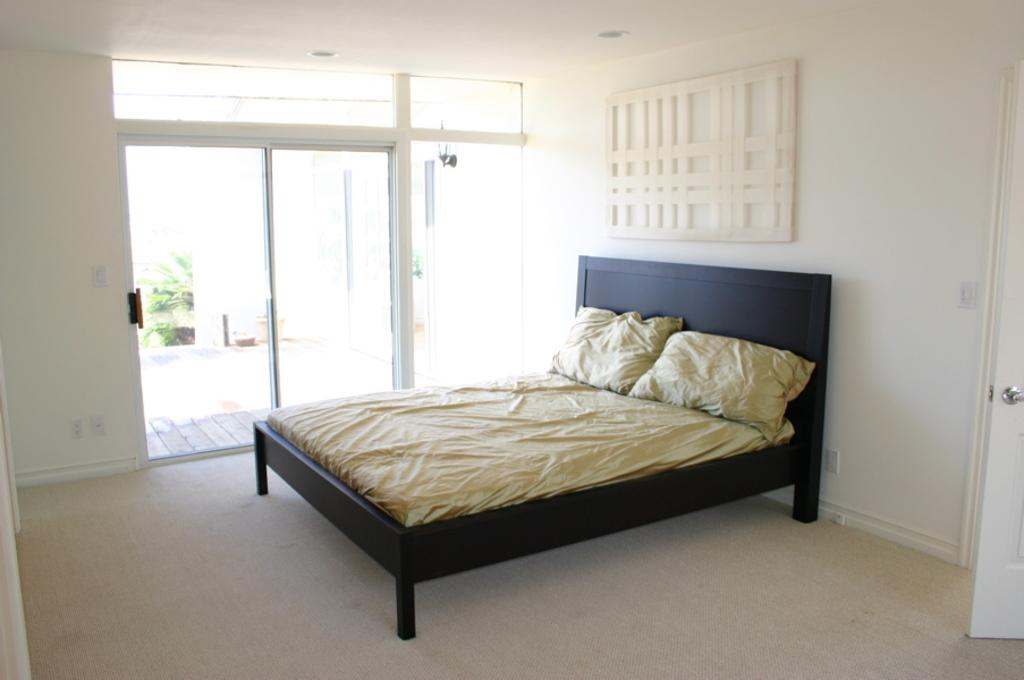What is the main object in the center of the image? There is a bed in the center of the image. What is covering the bed? There is a blanket on the bed. What is used for support and comfort while sleeping on the bed? There are pillows on the bed. What can be seen in the background of the image? There is a wall, a roof, a glass object, a door, switch boards, and other objects in the background of the image. What type of religion is being practiced in the image? There is no indication of any religious practice in the image; it primarily features a bed and various background objects. 